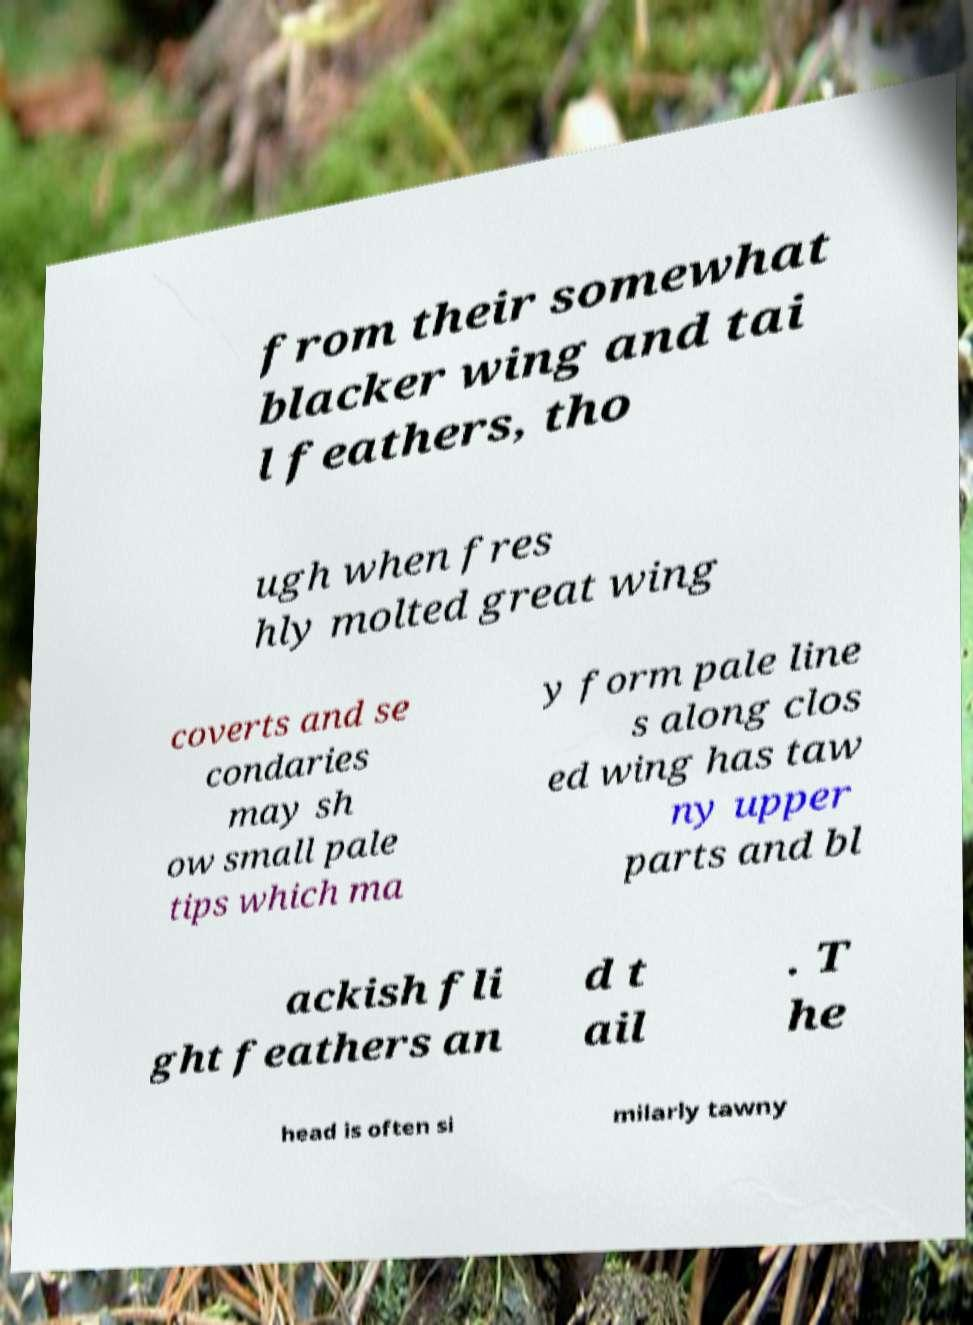Could you extract and type out the text from this image? from their somewhat blacker wing and tai l feathers, tho ugh when fres hly molted great wing coverts and se condaries may sh ow small pale tips which ma y form pale line s along clos ed wing has taw ny upper parts and bl ackish fli ght feathers an d t ail . T he head is often si milarly tawny 